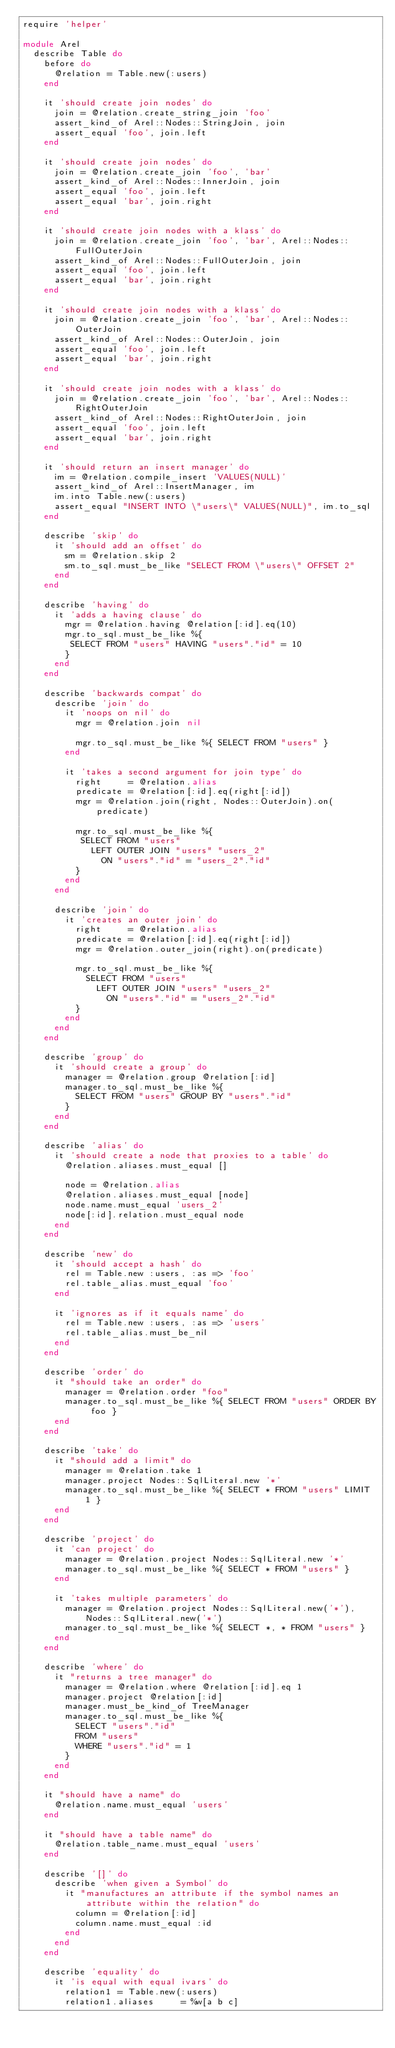<code> <loc_0><loc_0><loc_500><loc_500><_Ruby_>require 'helper'

module Arel
  describe Table do
    before do
      @relation = Table.new(:users)
    end

    it 'should create join nodes' do
      join = @relation.create_string_join 'foo'
      assert_kind_of Arel::Nodes::StringJoin, join
      assert_equal 'foo', join.left
    end

    it 'should create join nodes' do
      join = @relation.create_join 'foo', 'bar'
      assert_kind_of Arel::Nodes::InnerJoin, join
      assert_equal 'foo', join.left
      assert_equal 'bar', join.right
    end

    it 'should create join nodes with a klass' do
      join = @relation.create_join 'foo', 'bar', Arel::Nodes::FullOuterJoin
      assert_kind_of Arel::Nodes::FullOuterJoin, join
      assert_equal 'foo', join.left
      assert_equal 'bar', join.right
    end

    it 'should create join nodes with a klass' do
      join = @relation.create_join 'foo', 'bar', Arel::Nodes::OuterJoin
      assert_kind_of Arel::Nodes::OuterJoin, join
      assert_equal 'foo', join.left
      assert_equal 'bar', join.right
    end

    it 'should create join nodes with a klass' do
      join = @relation.create_join 'foo', 'bar', Arel::Nodes::RightOuterJoin
      assert_kind_of Arel::Nodes::RightOuterJoin, join
      assert_equal 'foo', join.left
      assert_equal 'bar', join.right
    end

    it 'should return an insert manager' do
      im = @relation.compile_insert 'VALUES(NULL)'
      assert_kind_of Arel::InsertManager, im
      im.into Table.new(:users)
      assert_equal "INSERT INTO \"users\" VALUES(NULL)", im.to_sql
    end

    describe 'skip' do
      it 'should add an offset' do
        sm = @relation.skip 2
        sm.to_sql.must_be_like "SELECT FROM \"users\" OFFSET 2"
      end
    end

    describe 'having' do
      it 'adds a having clause' do
        mgr = @relation.having @relation[:id].eq(10)
        mgr.to_sql.must_be_like %{
         SELECT FROM "users" HAVING "users"."id" = 10
        }
      end
    end

    describe 'backwards compat' do
      describe 'join' do
        it 'noops on nil' do
          mgr = @relation.join nil

          mgr.to_sql.must_be_like %{ SELECT FROM "users" }
        end

        it 'takes a second argument for join type' do
          right     = @relation.alias
          predicate = @relation[:id].eq(right[:id])
          mgr = @relation.join(right, Nodes::OuterJoin).on(predicate)

          mgr.to_sql.must_be_like %{
           SELECT FROM "users"
             LEFT OUTER JOIN "users" "users_2"
               ON "users"."id" = "users_2"."id"
          }
        end
      end

      describe 'join' do
        it 'creates an outer join' do
          right     = @relation.alias
          predicate = @relation[:id].eq(right[:id])
          mgr = @relation.outer_join(right).on(predicate)

          mgr.to_sql.must_be_like %{
            SELECT FROM "users"
              LEFT OUTER JOIN "users" "users_2"
                ON "users"."id" = "users_2"."id"
          }
        end
      end
    end

    describe 'group' do
      it 'should create a group' do
        manager = @relation.group @relation[:id]
        manager.to_sql.must_be_like %{
          SELECT FROM "users" GROUP BY "users"."id"
        }
      end
    end

    describe 'alias' do
      it 'should create a node that proxies to a table' do
        @relation.aliases.must_equal []

        node = @relation.alias
        @relation.aliases.must_equal [node]
        node.name.must_equal 'users_2'
        node[:id].relation.must_equal node
      end
    end

    describe 'new' do
      it 'should accept a hash' do
        rel = Table.new :users, :as => 'foo'
        rel.table_alias.must_equal 'foo'
      end

      it 'ignores as if it equals name' do
        rel = Table.new :users, :as => 'users'
        rel.table_alias.must_be_nil
      end
    end

    describe 'order' do
      it "should take an order" do
        manager = @relation.order "foo"
        manager.to_sql.must_be_like %{ SELECT FROM "users" ORDER BY foo }
      end
    end

    describe 'take' do
      it "should add a limit" do
        manager = @relation.take 1
        manager.project Nodes::SqlLiteral.new '*'
        manager.to_sql.must_be_like %{ SELECT * FROM "users" LIMIT 1 }
      end
    end

    describe 'project' do
      it 'can project' do
        manager = @relation.project Nodes::SqlLiteral.new '*'
        manager.to_sql.must_be_like %{ SELECT * FROM "users" }
      end

      it 'takes multiple parameters' do
        manager = @relation.project Nodes::SqlLiteral.new('*'), Nodes::SqlLiteral.new('*')
        manager.to_sql.must_be_like %{ SELECT *, * FROM "users" }
      end
    end

    describe 'where' do
      it "returns a tree manager" do
        manager = @relation.where @relation[:id].eq 1
        manager.project @relation[:id]
        manager.must_be_kind_of TreeManager
        manager.to_sql.must_be_like %{
          SELECT "users"."id"
          FROM "users"
          WHERE "users"."id" = 1
        }
      end
    end

    it "should have a name" do
      @relation.name.must_equal 'users'
    end

    it "should have a table name" do
      @relation.table_name.must_equal 'users'
    end

    describe '[]' do
      describe 'when given a Symbol' do
        it "manufactures an attribute if the symbol names an attribute within the relation" do
          column = @relation[:id]
          column.name.must_equal :id
        end
      end
    end

    describe 'equality' do
      it 'is equal with equal ivars' do
        relation1 = Table.new(:users)
        relation1.aliases     = %w[a b c]</code> 